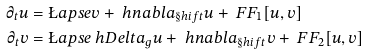Convert formula to latex. <formula><loc_0><loc_0><loc_500><loc_500>\partial _ { t } u & = \L a p s e v + \ h n a b l a _ { \S h i f t } u + \ F F _ { 1 } [ u , v ] \\ \partial _ { t } v & = \L a p s e \ h D e l t a _ { g } u + \ h n a b l a _ { \S h i f t } v + \ F F _ { 2 } [ u , v ]</formula> 